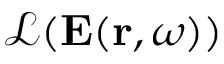<formula> <loc_0><loc_0><loc_500><loc_500>\mathcal { L } ( E ( r , \omega ) )</formula> 